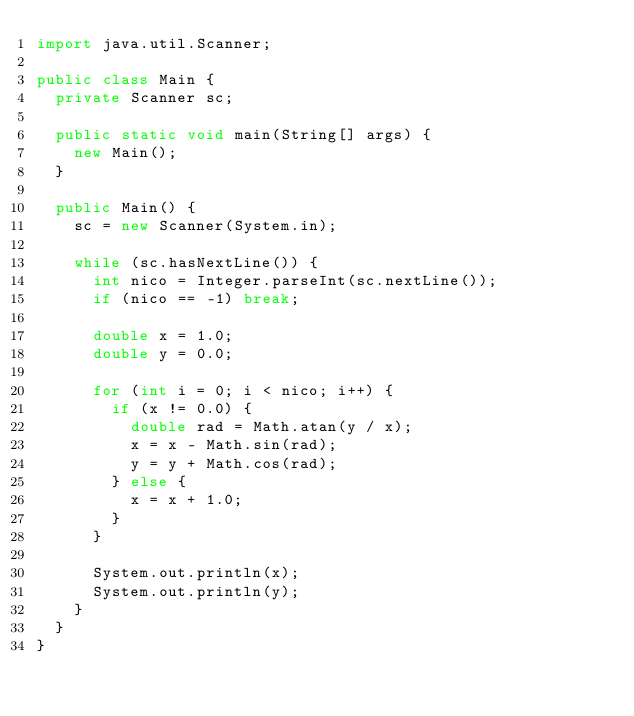Convert code to text. <code><loc_0><loc_0><loc_500><loc_500><_Java_>import java.util.Scanner;

public class Main {
	private Scanner sc;

	public static void main(String[] args) {
		new Main();
	}
	
	public Main() {
		sc = new Scanner(System.in);
		
		while (sc.hasNextLine()) {
			int nico = Integer.parseInt(sc.nextLine());
			if (nico == -1) break;
			
			double x = 1.0;
			double y = 0.0;
			
			for (int i = 0; i < nico; i++) {
				if (x != 0.0) {
					double rad = Math.atan(y / x);
					x = x - Math.sin(rad);
					y = y + Math.cos(rad);
				} else {
					x = x + 1.0;
				}
			}

			System.out.println(x);
			System.out.println(y);
		}
	}
}</code> 